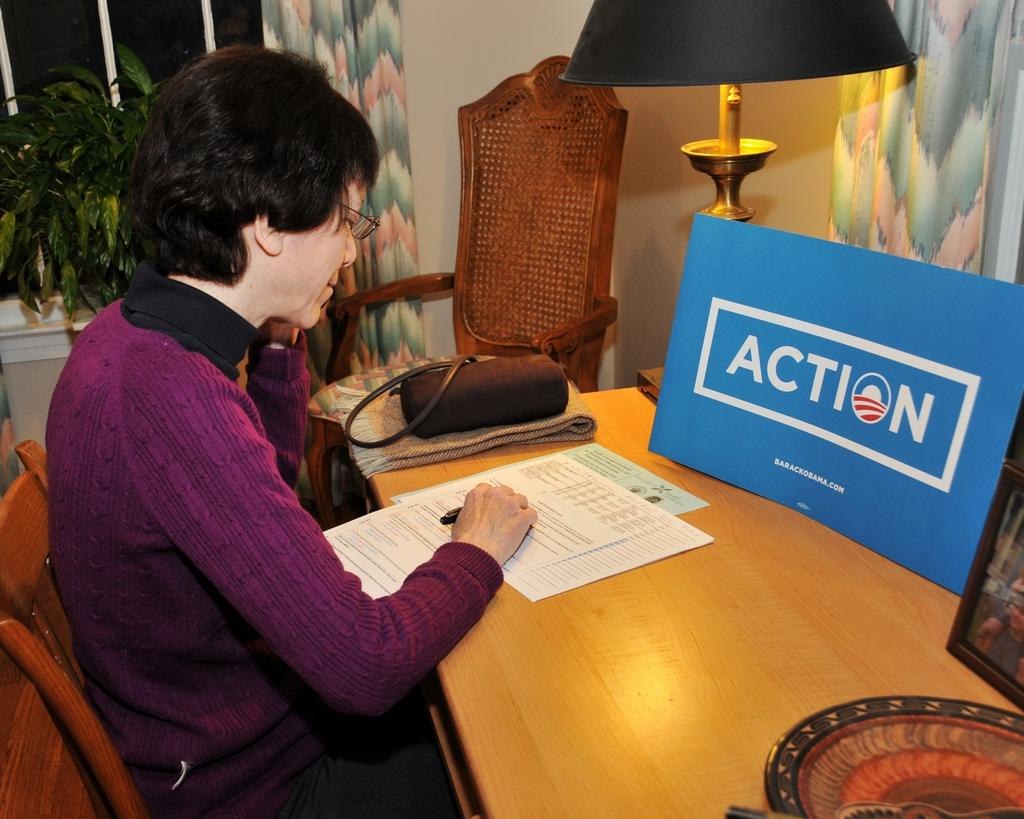<image>
Render a clear and concise summary of the photo. Action sign on a blue poster for barackobama.com website. 